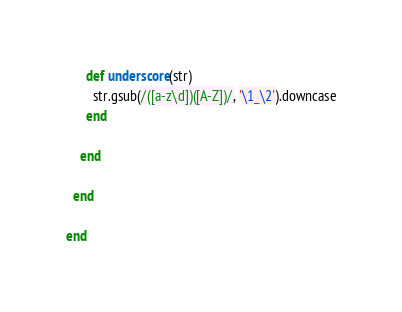<code> <loc_0><loc_0><loc_500><loc_500><_Ruby_>      def underscore(str)
        str.gsub(/([a-z\d])([A-Z])/, '\1_\2').downcase
      end

    end

  end

end
</code> 